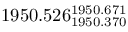<formula> <loc_0><loc_0><loc_500><loc_500>1 9 5 0 . 5 2 6 _ { 1 9 5 0 . 3 7 0 } ^ { 1 9 5 0 . 6 7 1 }</formula> 